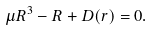Convert formula to latex. <formula><loc_0><loc_0><loc_500><loc_500>\mu R ^ { 3 } - R + D ( r ) = 0 .</formula> 